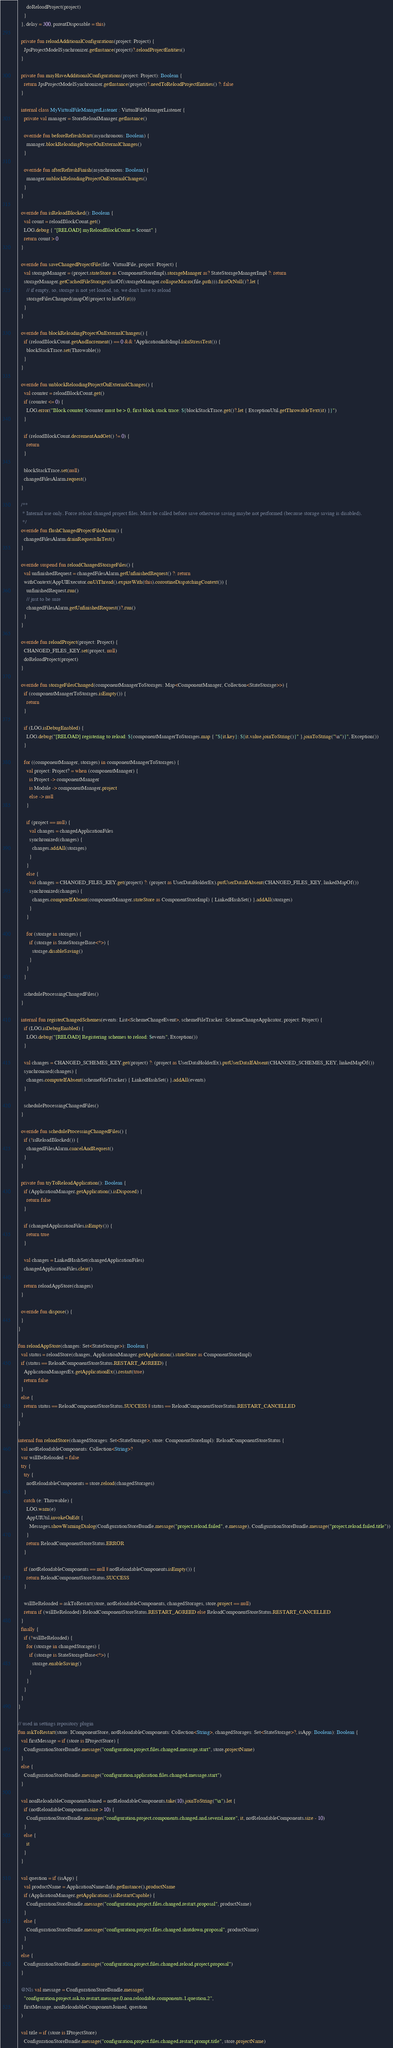<code> <loc_0><loc_0><loc_500><loc_500><_Kotlin_>      doReloadProject(project)
    }
  }, delay = 300, parentDisposable = this)

  private fun reloadAdditionalConfigurations(project: Project) {
    JpsProjectModelSynchronizer.getInstance(project)?.reloadProjectEntities()
  }

  private fun mayHaveAdditionalConfigurations(project: Project): Boolean {
    return JpsProjectModelSynchronizer.getInstance(project)?.needToReloadProjectEntities() ?: false
  }

  internal class MyVirtualFileManagerListener : VirtualFileManagerListener {
    private val manager = StoreReloadManager.getInstance()

    override fun beforeRefreshStart(asynchronous: Boolean) {
      manager.blockReloadingProjectOnExternalChanges()
    }

    override fun afterRefreshFinish(asynchronous: Boolean) {
      manager.unblockReloadingProjectOnExternalChanges()
    }
  }

  override fun isReloadBlocked(): Boolean {
    val count = reloadBlockCount.get()
    LOG.debug { "[RELOAD] myReloadBlockCount = $count" }
    return count > 0
  }

  override fun saveChangedProjectFile(file: VirtualFile, project: Project) {
    val storageManager = (project.stateStore as ComponentStoreImpl).storageManager as? StateStorageManagerImpl ?: return
    storageManager.getCachedFileStorages(listOf(storageManager.collapseMacro(file.path))).firstOrNull()?.let {
      // if empty, so, storage is not yet loaded, so, we don't have to reload
      storageFilesChanged(mapOf(project to listOf(it)))
    }
  }

  override fun blockReloadingProjectOnExternalChanges() {
    if (reloadBlockCount.getAndIncrement() == 0 && !ApplicationInfoImpl.isInStressTest()) {
      blockStackTrace.set(Throwable())
    }
  }

  override fun unblockReloadingProjectOnExternalChanges() {
    val counter = reloadBlockCount.get()
    if (counter <= 0) {
      LOG.error("Block counter $counter must be > 0, first block stack trace: ${blockStackTrace.get()?.let { ExceptionUtil.getThrowableText(it) }}")
    }

    if (reloadBlockCount.decrementAndGet() != 0) {
      return
    }

    blockStackTrace.set(null)
    changedFilesAlarm.request()
  }

  /**
   * Internal use only. Force reload changed project files. Must be called before save otherwise saving maybe not performed (because storage saving is disabled).
   */
  override fun flushChangedProjectFileAlarm() {
    changedFilesAlarm.drainRequestsInTest()
  }

  override suspend fun reloadChangedStorageFiles() {
    val unfinishedRequest = changedFilesAlarm.getUnfinishedRequest() ?: return
    withContext(AppUIExecutor.onUiThread().expireWith(this).coroutineDispatchingContext()) {
      unfinishedRequest.run()
      // just to be sure
      changedFilesAlarm.getUnfinishedRequest()?.run()
    }
  }

  override fun reloadProject(project: Project) {
    CHANGED_FILES_KEY.set(project, null)
    doReloadProject(project)
  }

  override fun storageFilesChanged(componentManagerToStorages: Map<ComponentManager, Collection<StateStorage>>) {
    if (componentManagerToStorages.isEmpty()) {
      return
    }

    if (LOG.isDebugEnabled) {
      LOG.debug("[RELOAD] registering to reload: ${componentManagerToStorages.map { "${it.key}: ${it.value.joinToString()}" }.joinToString("\n")}", Exception())
    }

    for ((componentManager, storages) in componentManagerToStorages) {
      val project: Project? = when (componentManager) {
        is Project -> componentManager
        is Module -> componentManager.project
        else -> null
      }

      if (project == null) {
        val changes = changedApplicationFiles
        synchronized(changes) {
          changes.addAll(storages)
        }
      }
      else {
        val changes = CHANGED_FILES_KEY.get(project) ?: (project as UserDataHolderEx).putUserDataIfAbsent(CHANGED_FILES_KEY, linkedMapOf())
        synchronized(changes) {
          changes.computeIfAbsent(componentManager.stateStore as ComponentStoreImpl) { LinkedHashSet() }.addAll(storages)
        }
      }

      for (storage in storages) {
        if (storage is StateStorageBase<*>) {
          storage.disableSaving()
        }
      }
    }

    scheduleProcessingChangedFiles()
  }

  internal fun registerChangedSchemes(events: List<SchemeChangeEvent>, schemeFileTracker: SchemeChangeApplicator, project: Project) {
    if (LOG.isDebugEnabled) {
      LOG.debug("[RELOAD] Registering schemes to reload: $events", Exception())
    }

    val changes = CHANGED_SCHEMES_KEY.get(project) ?: (project as UserDataHolderEx).putUserDataIfAbsent(CHANGED_SCHEMES_KEY, linkedMapOf())
    synchronized(changes) {
      changes.computeIfAbsent(schemeFileTracker) { LinkedHashSet() }.addAll(events)
    }

    scheduleProcessingChangedFiles()
  }

  override fun scheduleProcessingChangedFiles() {
    if (!isReloadBlocked()) {
      changedFilesAlarm.cancelAndRequest()
    }
  }

  private fun tryToReloadApplication(): Boolean {
    if (ApplicationManager.getApplication().isDisposed) {
      return false
    }

    if (changedApplicationFiles.isEmpty()) {
      return true
    }

    val changes = LinkedHashSet(changedApplicationFiles)
    changedApplicationFiles.clear()

    return reloadAppStore(changes)
  }

  override fun dispose() {
  }
}

fun reloadAppStore(changes: Set<StateStorage>): Boolean {
  val status = reloadStore(changes, ApplicationManager.getApplication().stateStore as ComponentStoreImpl)
  if (status == ReloadComponentStoreStatus.RESTART_AGREED) {
    ApplicationManagerEx.getApplicationEx().restart(true)
    return false
  }
  else {
    return status == ReloadComponentStoreStatus.SUCCESS || status == ReloadComponentStoreStatus.RESTART_CANCELLED
  }
}

internal fun reloadStore(changedStorages: Set<StateStorage>, store: ComponentStoreImpl): ReloadComponentStoreStatus {
  val notReloadableComponents: Collection<String>?
  var willBeReloaded = false
  try {
    try {
      notReloadableComponents = store.reload(changedStorages)
    }
    catch (e: Throwable) {
      LOG.warn(e)
      AppUIUtil.invokeOnEdt {
        Messages.showWarningDialog(ConfigurationStoreBundle.message("project.reload.failed", e.message), ConfigurationStoreBundle.message("project.reload.failed.title"))
      }
      return ReloadComponentStoreStatus.ERROR
    }

    if (notReloadableComponents == null || notReloadableComponents.isEmpty()) {
      return ReloadComponentStoreStatus.SUCCESS
    }

    willBeReloaded = askToRestart(store, notReloadableComponents, changedStorages, store.project == null)
    return if (willBeReloaded) ReloadComponentStoreStatus.RESTART_AGREED else ReloadComponentStoreStatus.RESTART_CANCELLED
  }
  finally {
    if (!willBeReloaded) {
      for (storage in changedStorages) {
        if (storage is StateStorageBase<*>) {
          storage.enableSaving()
        }
      }
    }
  }
}

// used in settings repository plugin
fun askToRestart(store: IComponentStore, notReloadableComponents: Collection<String>, changedStorages: Set<StateStorage>?, isApp: Boolean): Boolean {
  val firstMessage = if (store is IProjectStore) {
    ConfigurationStoreBundle.message("configuration.project.files.changed.message.start", store.projectName)
  }
  else {
    ConfigurationStoreBundle.message("configuration.application.files.changed.message.start")
  }

  val nonReloadableComponentsJoined = notReloadableComponents.take(10).joinToString("\n").let {
    if (notReloadableComponents.size > 10) {
      ConfigurationStoreBundle.message("configuration.project.components.changed.and.several.more", it, notReloadableComponents.size - 10)
    }
    else {
      it
    }
  }

  val question = if (isApp) {
    val productName = ApplicationNamesInfo.getInstance().productName
    if (ApplicationManager.getApplication().isRestartCapable) {
      ConfigurationStoreBundle.message("configuration.project.files.changed.restart.proposal", productName)
    }
    else {
      ConfigurationStoreBundle.message("configuration.project.files.changed.shutdown.proposal", productName)
    }
  }
  else {
    ConfigurationStoreBundle.message("configuration.project.files.changed.reload.project.proposal")
  }

  @Nls val message = ConfigurationStoreBundle.message(
    "configuration.project.ask.to.restart.message.0.non.reloadable.components.1.question.2",
    firstMessage, nonReloadableComponentsJoined, question
  )

  val title = if (store is IProjectStore)
    ConfigurationStoreBundle.message("configuration.project.files.changed.restart.prompt.title", store.projectName)</code> 